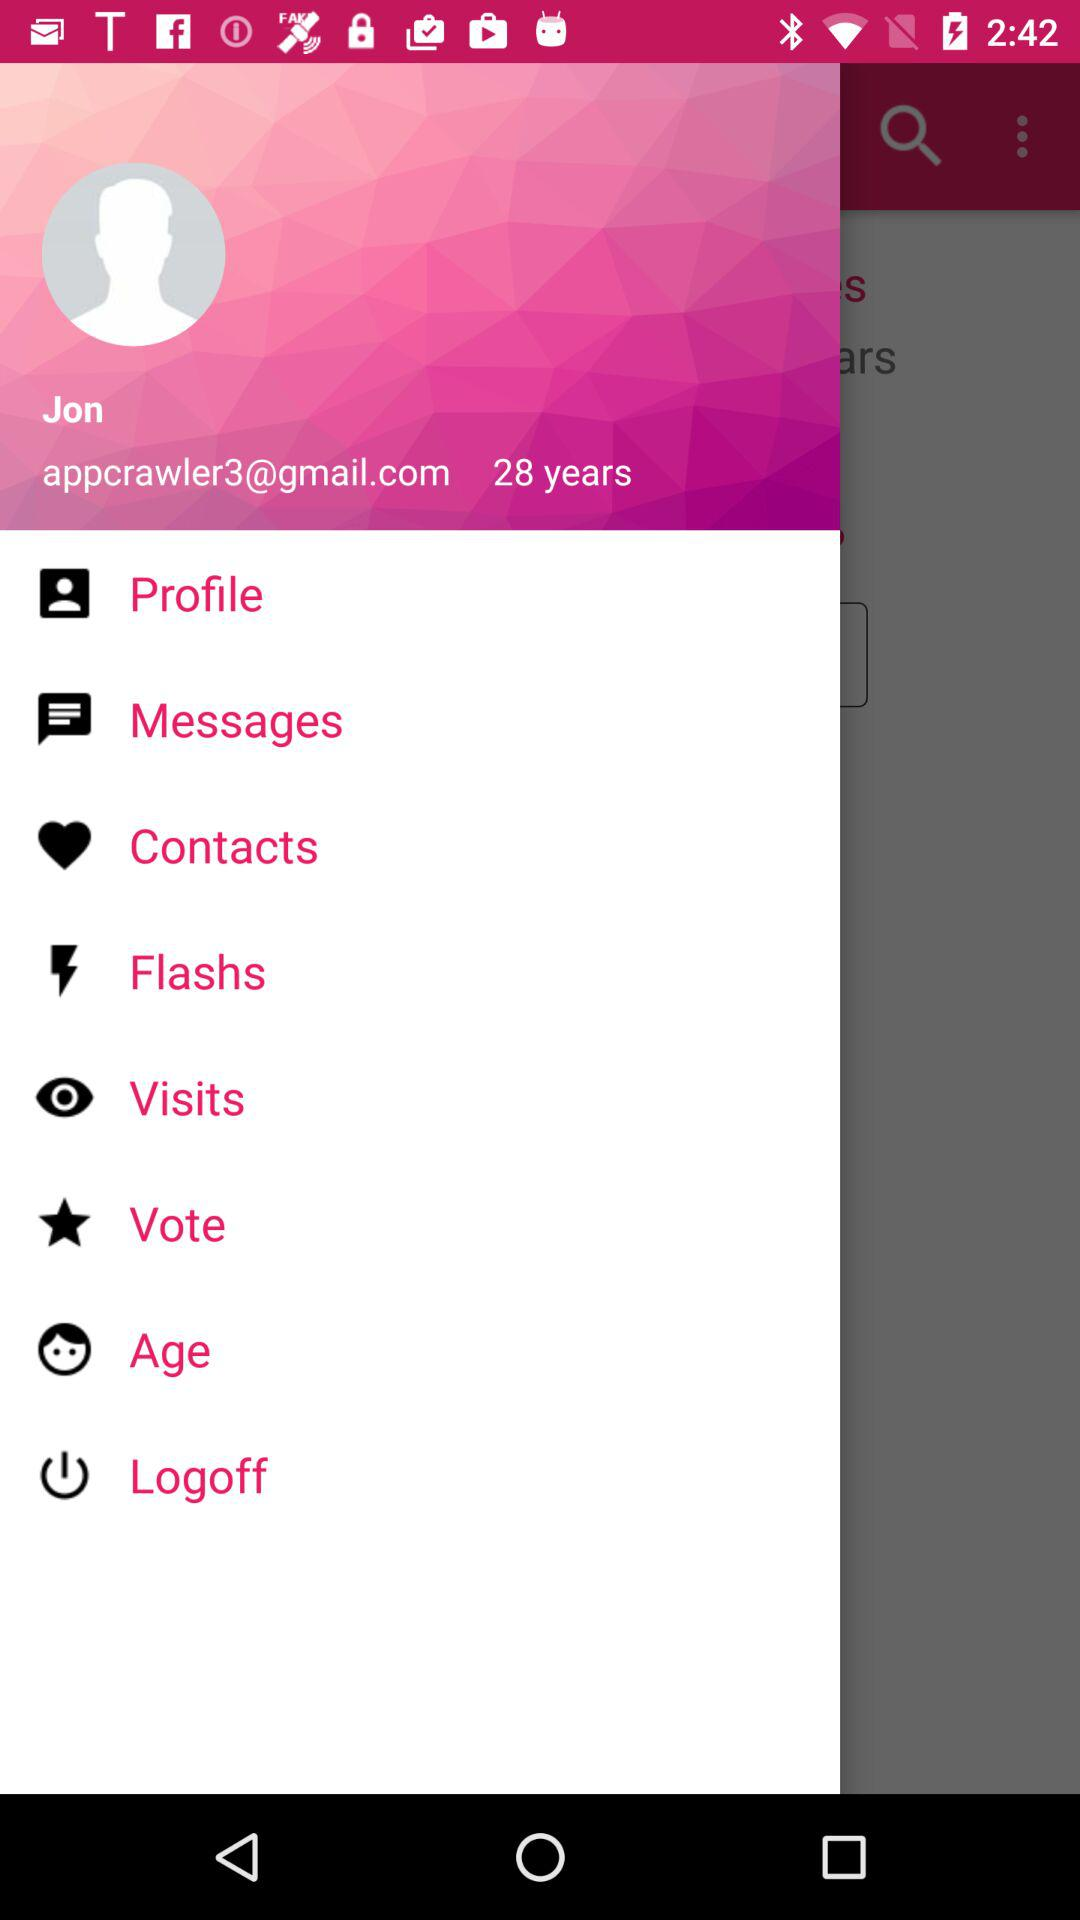What is the name of the user? The name of the user is Jon. 